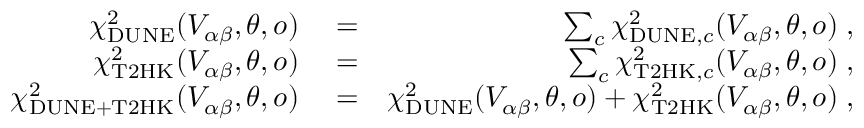Convert formula to latex. <formula><loc_0><loc_0><loc_500><loc_500>\begin{array} { r l r } { \chi _ { D U N E } ^ { 2 } ( V _ { \alpha \beta } , \theta , o ) } & = } & { \sum _ { c } \chi _ { D U N E , c } ^ { 2 } ( V _ { \alpha \beta } , \theta , o ) \, , } \\ { \chi _ { T 2 H K } ^ { 2 } ( V _ { \alpha \beta } , \theta , o ) } & = } & { \sum _ { c } \chi _ { T 2 H K , c } ^ { 2 } ( V _ { \alpha \beta } , \theta , o ) \, , } \\ { \chi _ { D U N E + T 2 H K } ^ { 2 } ( V _ { \alpha \beta } , \theta , o ) } & = } & { \chi _ { D U N E } ^ { 2 } ( V _ { \alpha \beta } , \theta , o ) + \chi _ { T 2 H K } ^ { 2 } ( V _ { \alpha \beta } , \theta , o ) \, , } \end{array}</formula> 